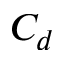<formula> <loc_0><loc_0><loc_500><loc_500>C _ { d }</formula> 